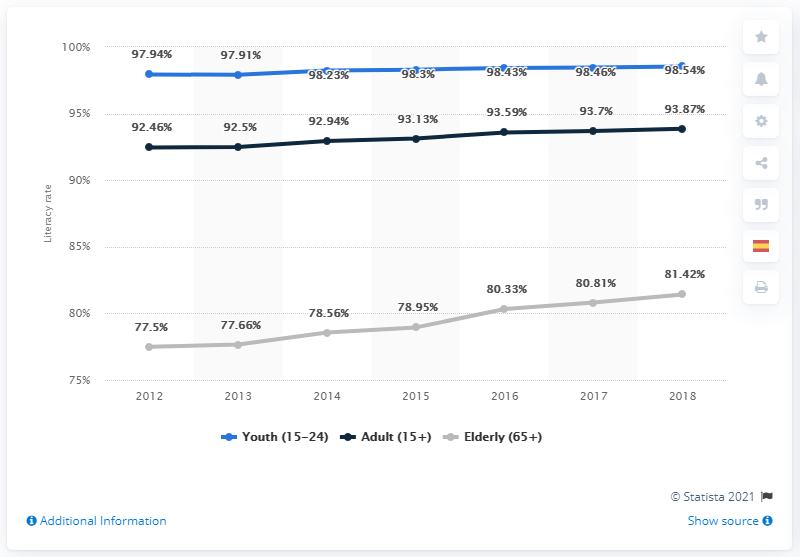Outline some significant characteristics in this image. In 2018, the adult literacy rate in Latin America and the Caribbean was 93.87%. The literacy rate in Latin America and the Caribbean was significantly higher than the worldwide average, with a literacy rate of 93.87%. 